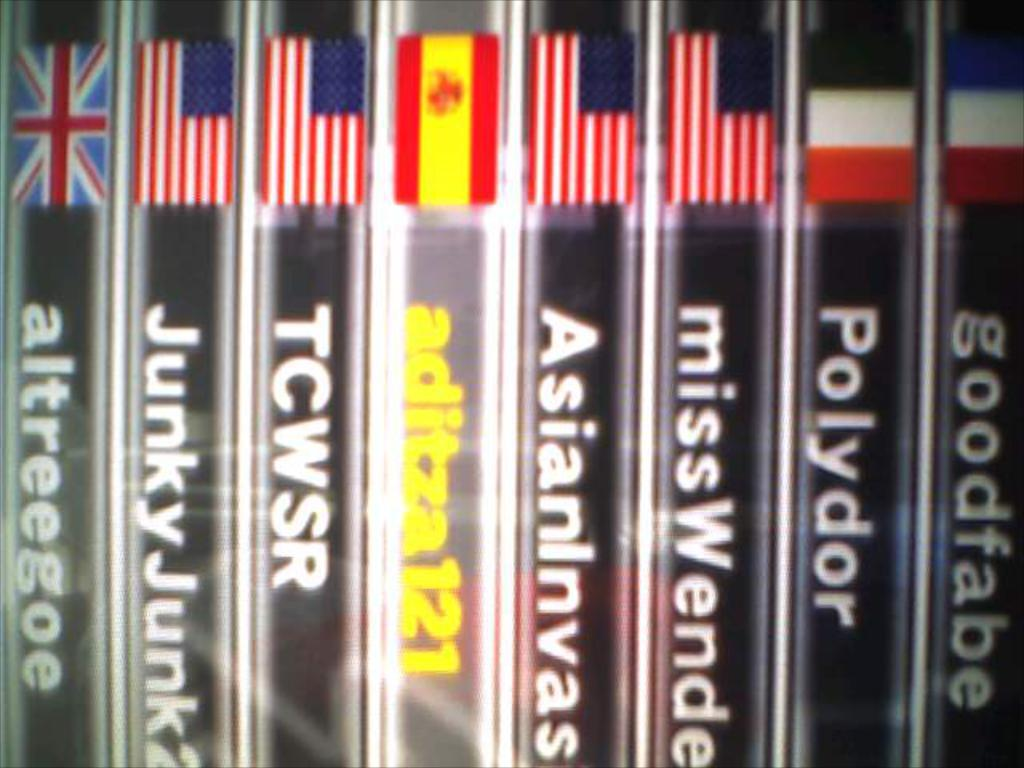<image>
Relay a brief, clear account of the picture shown. A selection of country flags and words underneath such as goodfabe, and polydor. 